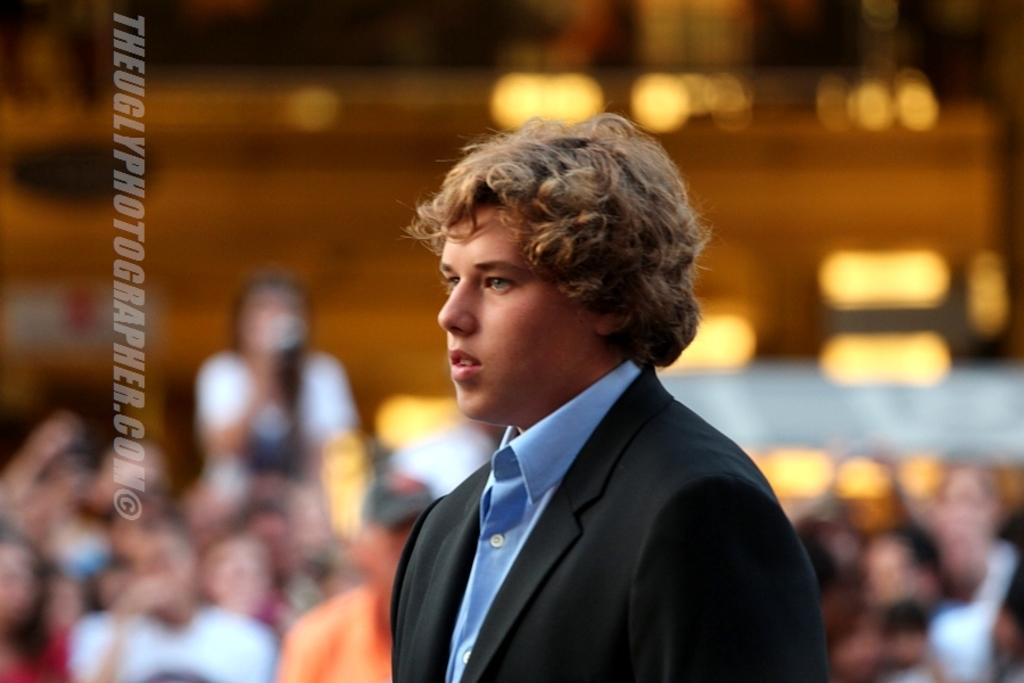Who is present in the image? There is a person in the image. What is the person wearing on their upper body? The person is wearing a blue shirt and a black coat. Can you describe the surroundings of the person? There are people in the background of the image. What type of powder is being used by the person in the image? There is no powder visible in the image, and the person's actions are not described. 